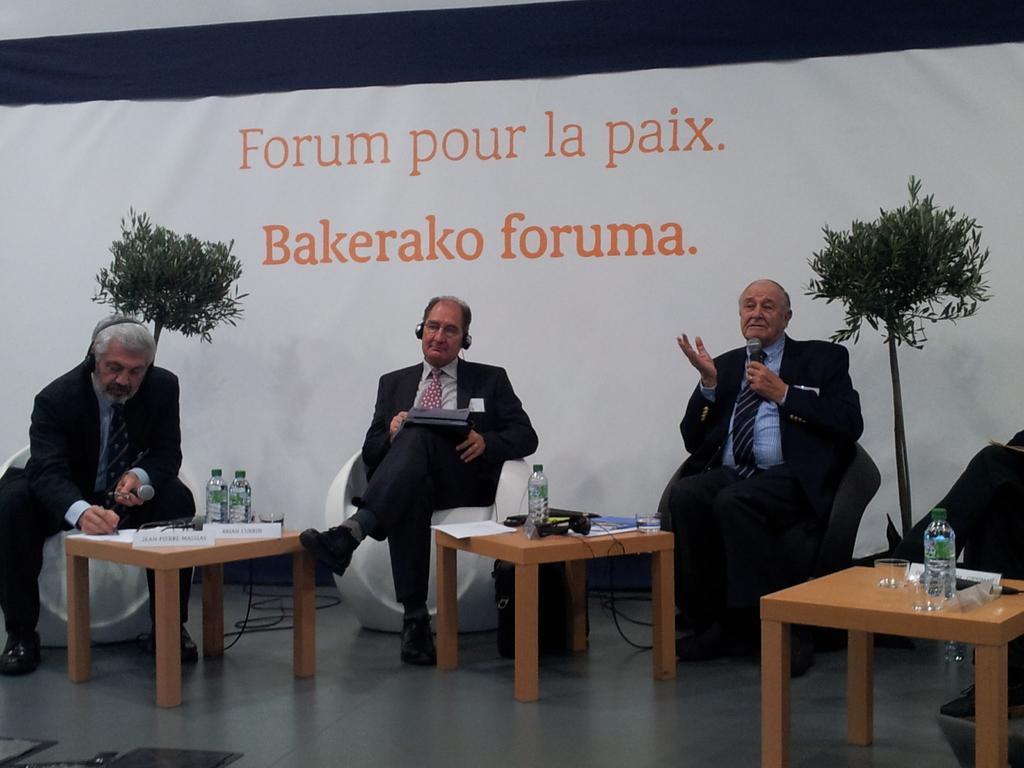Could you give a brief overview of what you see in this image? This image consist of three men sitting in the sofas. They are wearing black suits. In front of them, there are tables on which bottles and name plates are kept. In the background, there is a banner, and two plants. 